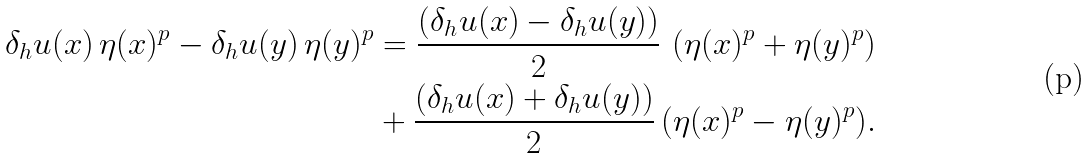Convert formula to latex. <formula><loc_0><loc_0><loc_500><loc_500>\delta _ { h } u ( x ) \, \eta ( x ) ^ { p } - \delta _ { h } u ( y ) \, \eta ( y ) ^ { p } & = \frac { \left ( \delta _ { h } u ( x ) - \delta _ { h } u ( y ) \right ) } { 2 } \, \left ( \eta ( x ) ^ { p } + \eta ( y ) ^ { p } \right ) \\ & + \frac { \left ( \delta _ { h } u ( x ) + \delta _ { h } u ( y ) \right ) } { 2 } \, ( \eta ( x ) ^ { p } - \eta ( y ) ^ { p } ) .</formula> 